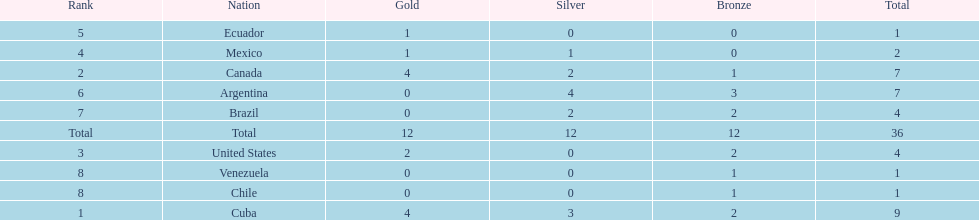Can you parse all the data within this table? {'header': ['Rank', 'Nation', 'Gold', 'Silver', 'Bronze', 'Total'], 'rows': [['5', 'Ecuador', '1', '0', '0', '1'], ['4', 'Mexico', '1', '1', '0', '2'], ['2', 'Canada', '4', '2', '1', '7'], ['6', 'Argentina', '0', '4', '3', '7'], ['7', 'Brazil', '0', '2', '2', '4'], ['Total', 'Total', '12', '12', '12', '36'], ['3', 'United States', '2', '0', '2', '4'], ['8', 'Venezuela', '0', '0', '1', '1'], ['8', 'Chile', '0', '0', '1', '1'], ['1', 'Cuba', '4', '3', '2', '9']]} Which is the only nation to win a gold medal and nothing else? Ecuador. 